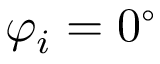<formula> <loc_0><loc_0><loc_500><loc_500>\varphi _ { i } = 0 ^ { \circ }</formula> 